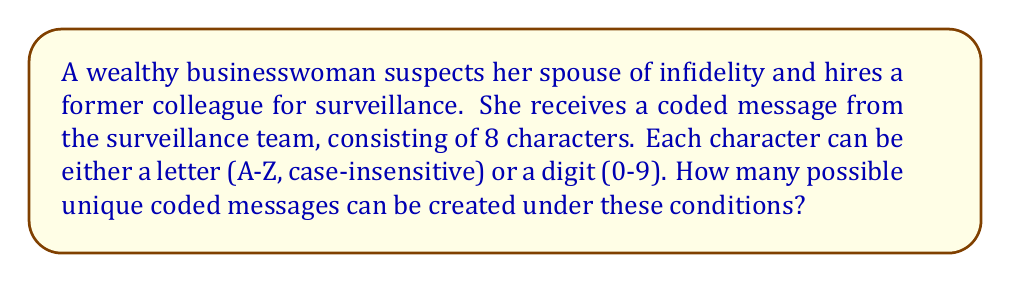Teach me how to tackle this problem. To solve this problem, we need to determine the number of possible combinations for the coded message. Let's break it down step by step:

1. Number of characters in the message: 8

2. Possible options for each character:
   - Letters (A-Z, case-insensitive): 26
   - Digits (0-9): 10
   Total options per character: 26 + 10 = 36

3. Using the multiplication principle, we can calculate the total number of possible combinations:

   $$ \text{Total combinations} = 36^8 $$

   This is because for each of the 8 positions, we have 36 choices, and these choices are independent of each other.

4. Let's calculate this value:

   $$ 36^8 = 2,821,109,907,456 $$

Therefore, there are 2,821,109,907,456 possible unique coded messages that can be created under these conditions.
Answer: $$ 36^8 = 2,821,109,907,456 $$ 